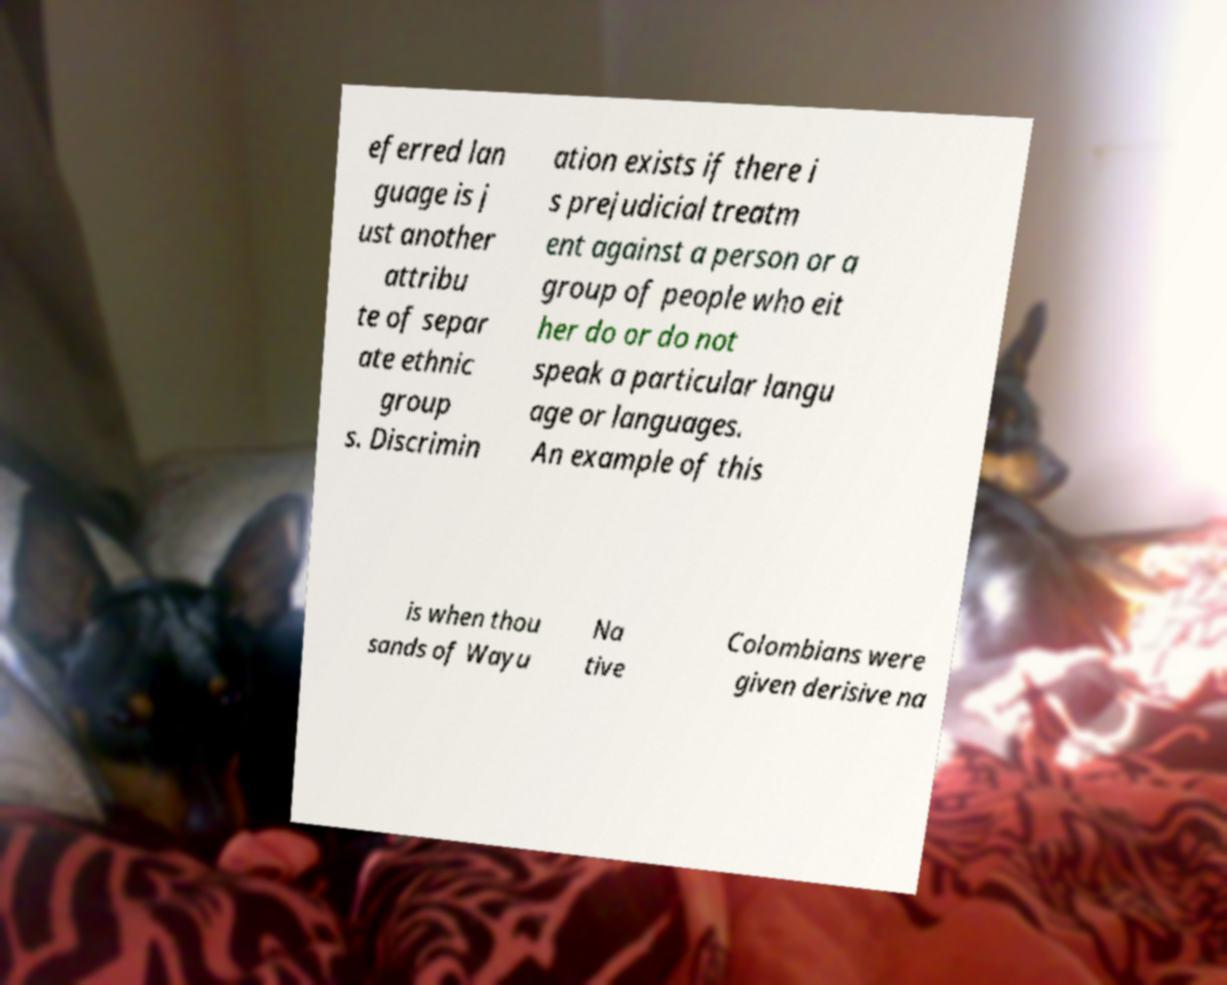Can you read and provide the text displayed in the image?This photo seems to have some interesting text. Can you extract and type it out for me? eferred lan guage is j ust another attribu te of separ ate ethnic group s. Discrimin ation exists if there i s prejudicial treatm ent against a person or a group of people who eit her do or do not speak a particular langu age or languages. An example of this is when thou sands of Wayu Na tive Colombians were given derisive na 